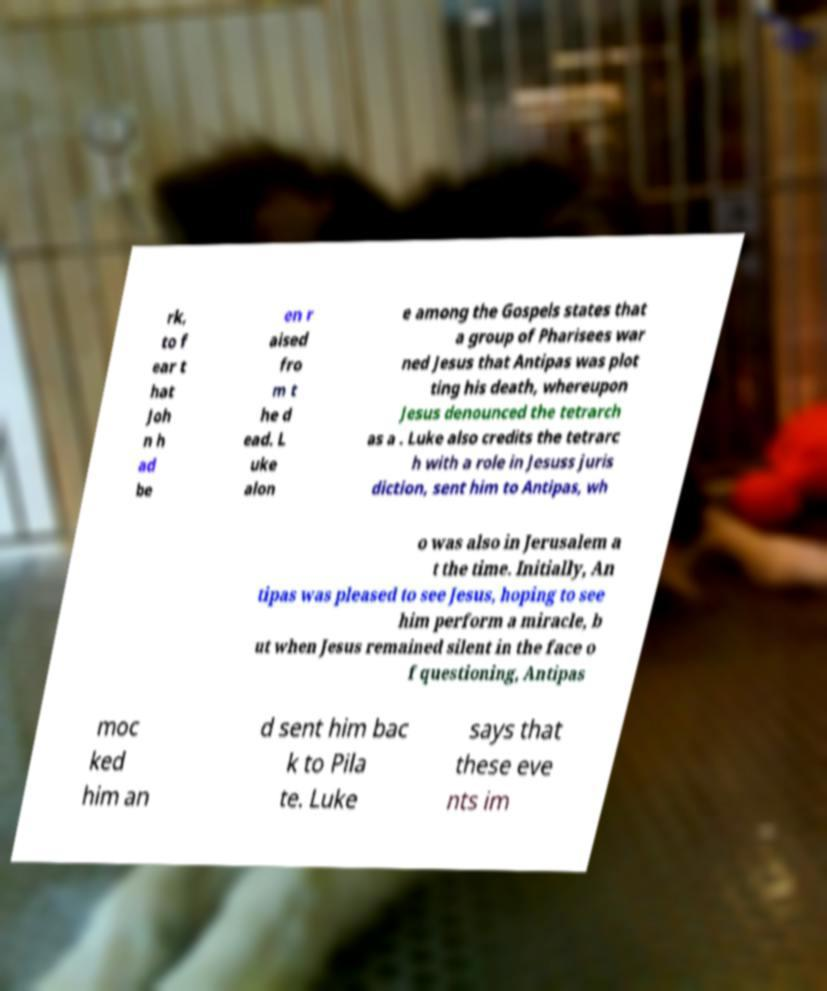Can you accurately transcribe the text from the provided image for me? rk, to f ear t hat Joh n h ad be en r aised fro m t he d ead. L uke alon e among the Gospels states that a group of Pharisees war ned Jesus that Antipas was plot ting his death, whereupon Jesus denounced the tetrarch as a . Luke also credits the tetrarc h with a role in Jesuss juris diction, sent him to Antipas, wh o was also in Jerusalem a t the time. Initially, An tipas was pleased to see Jesus, hoping to see him perform a miracle, b ut when Jesus remained silent in the face o f questioning, Antipas moc ked him an d sent him bac k to Pila te. Luke says that these eve nts im 